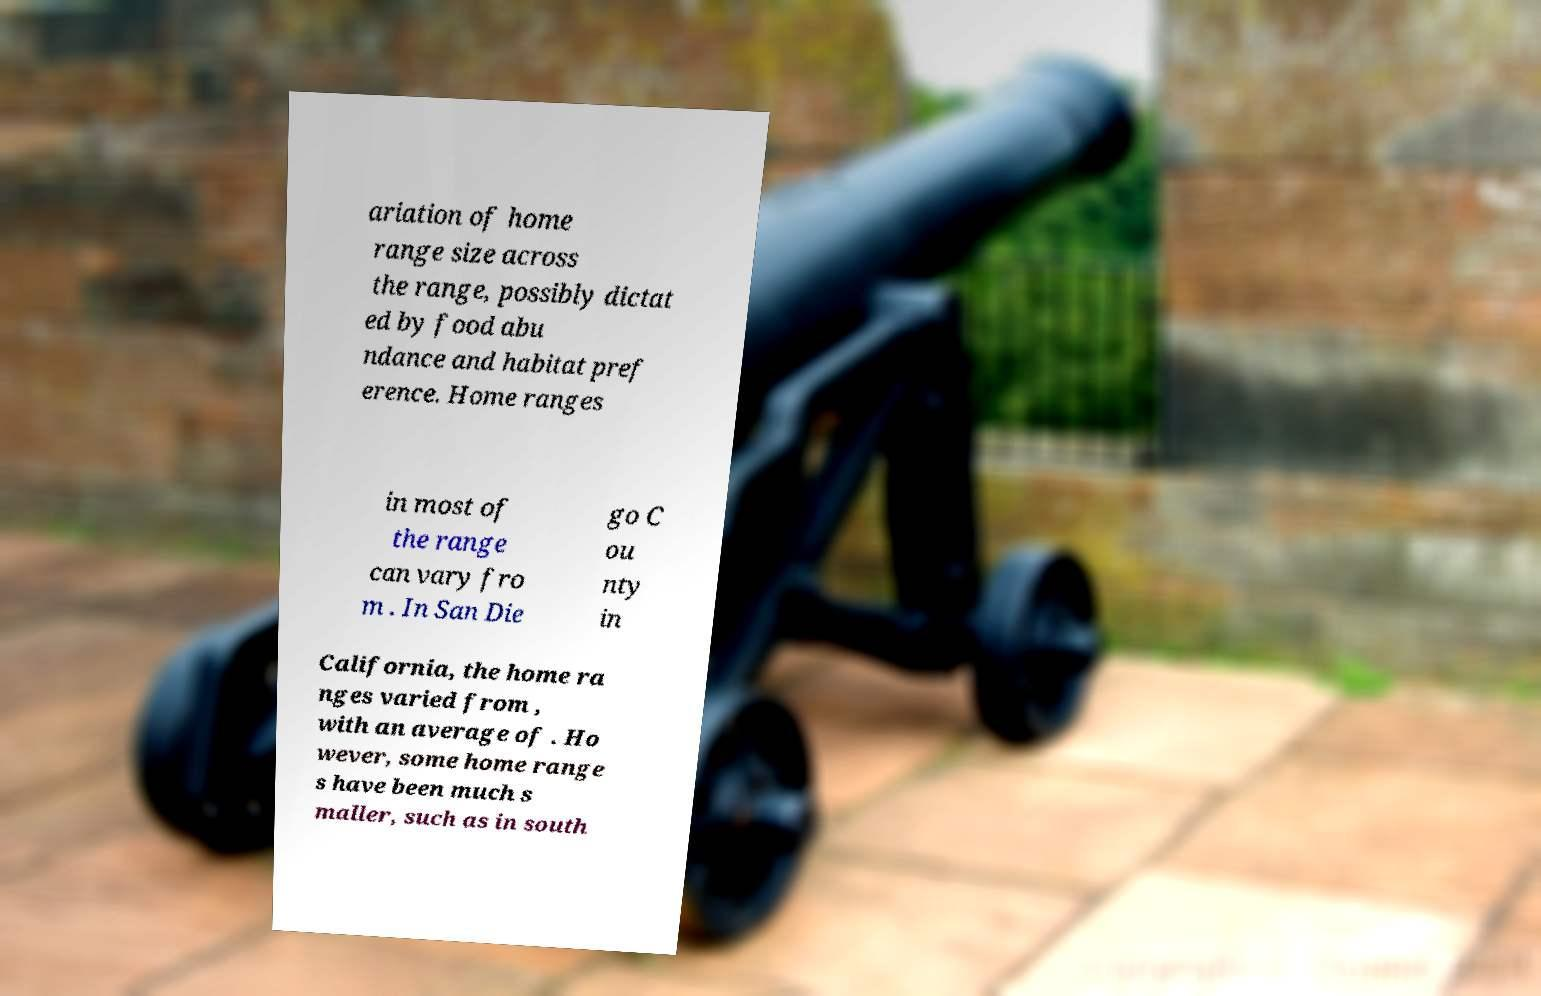I need the written content from this picture converted into text. Can you do that? ariation of home range size across the range, possibly dictat ed by food abu ndance and habitat pref erence. Home ranges in most of the range can vary fro m . In San Die go C ou nty in California, the home ra nges varied from , with an average of . Ho wever, some home range s have been much s maller, such as in south 